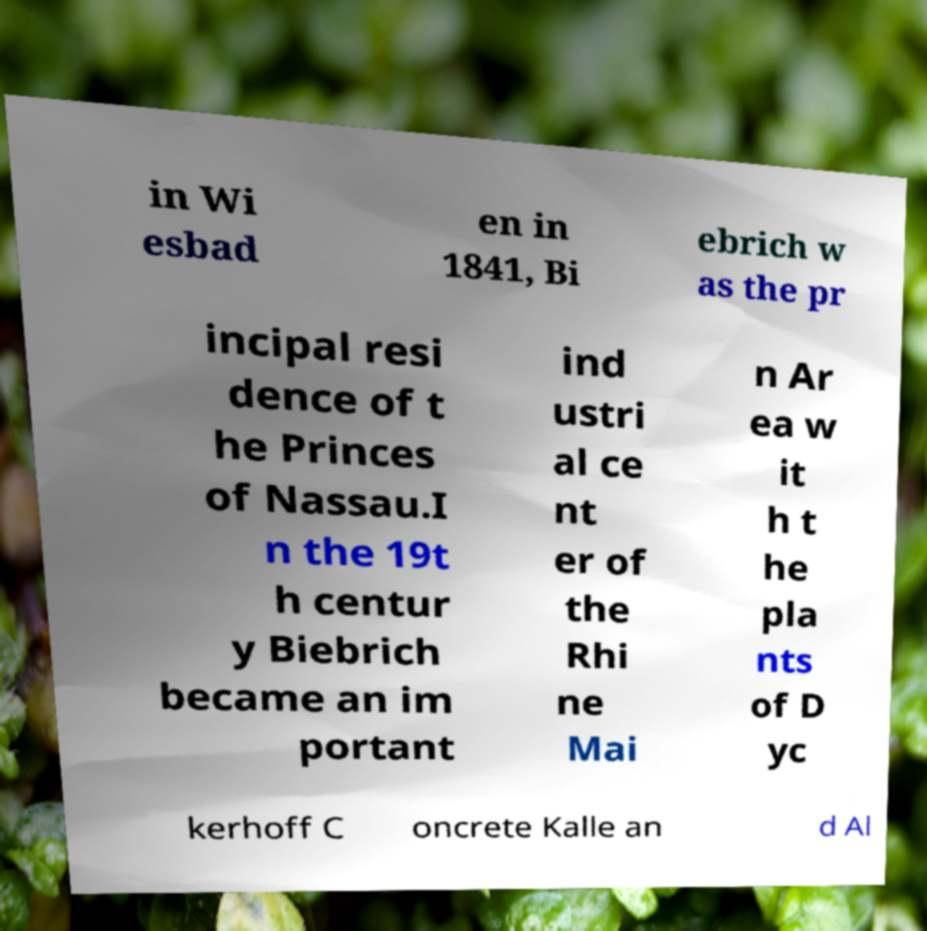What messages or text are displayed in this image? I need them in a readable, typed format. in Wi esbad en in 1841, Bi ebrich w as the pr incipal resi dence of t he Princes of Nassau.I n the 19t h centur y Biebrich became an im portant ind ustri al ce nt er of the Rhi ne Mai n Ar ea w it h t he pla nts of D yc kerhoff C oncrete Kalle an d Al 